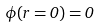Convert formula to latex. <formula><loc_0><loc_0><loc_500><loc_500>\phi ( r = 0 ) = 0</formula> 